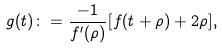Convert formula to latex. <formula><loc_0><loc_0><loc_500><loc_500>g ( t ) \colon = \frac { - 1 } { f ^ { \prime } ( \rho ) } [ f ( t + \rho ) + 2 \rho ] ,</formula> 